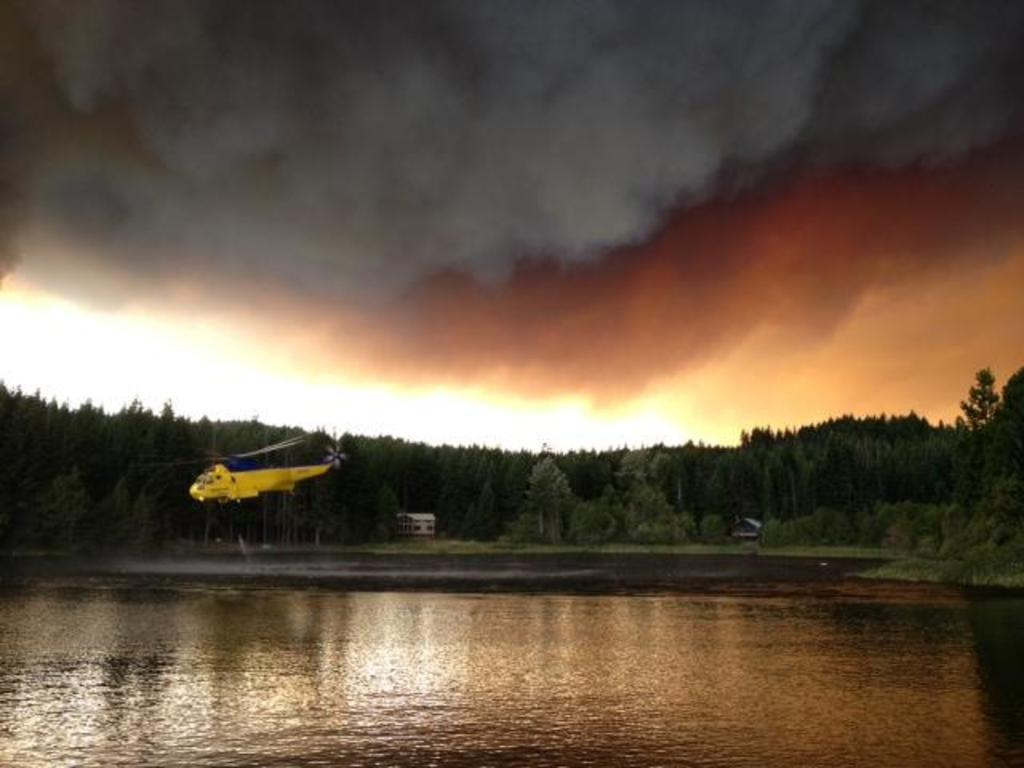What is the primary element visible in the image? There is water in the image. What can be seen flying above the water? There is a yellow helicopter above the water. What type of vegetation is visible in the background of the image? There are trees in the background of the image. What type of structure is visible in the background of the image? There is a building in the background of the image. What is the source of the smoke visible above the water? The source of the smoke is not specified in the image, but it is visible above the water. How many dolls are visible in the image? There are no dolls present in the image. What type of debt is being discussed in the image? There is no discussion of debt in the image. 